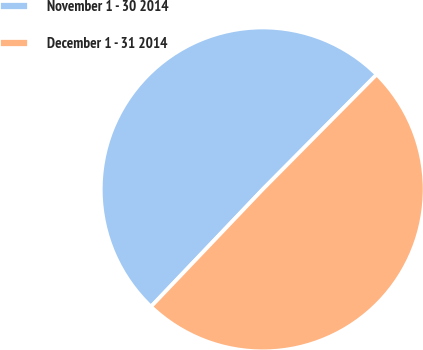Convert chart to OTSL. <chart><loc_0><loc_0><loc_500><loc_500><pie_chart><fcel>November 1 - 30 2014<fcel>December 1 - 31 2014<nl><fcel>50.32%<fcel>49.68%<nl></chart> 